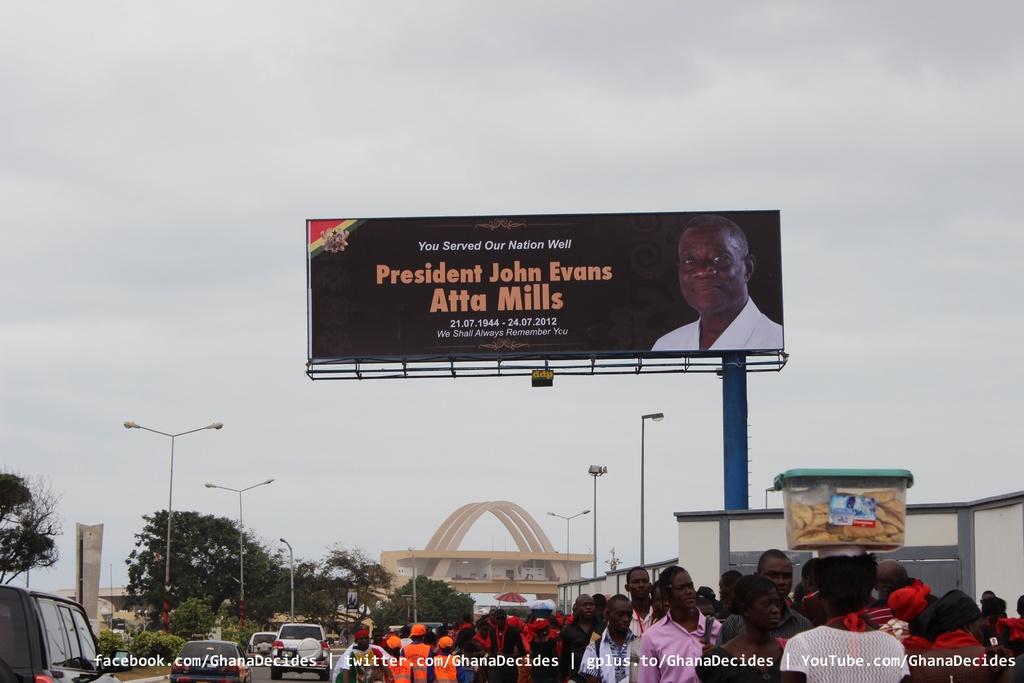Who's the president?
Ensure brevity in your answer.  John evans. 